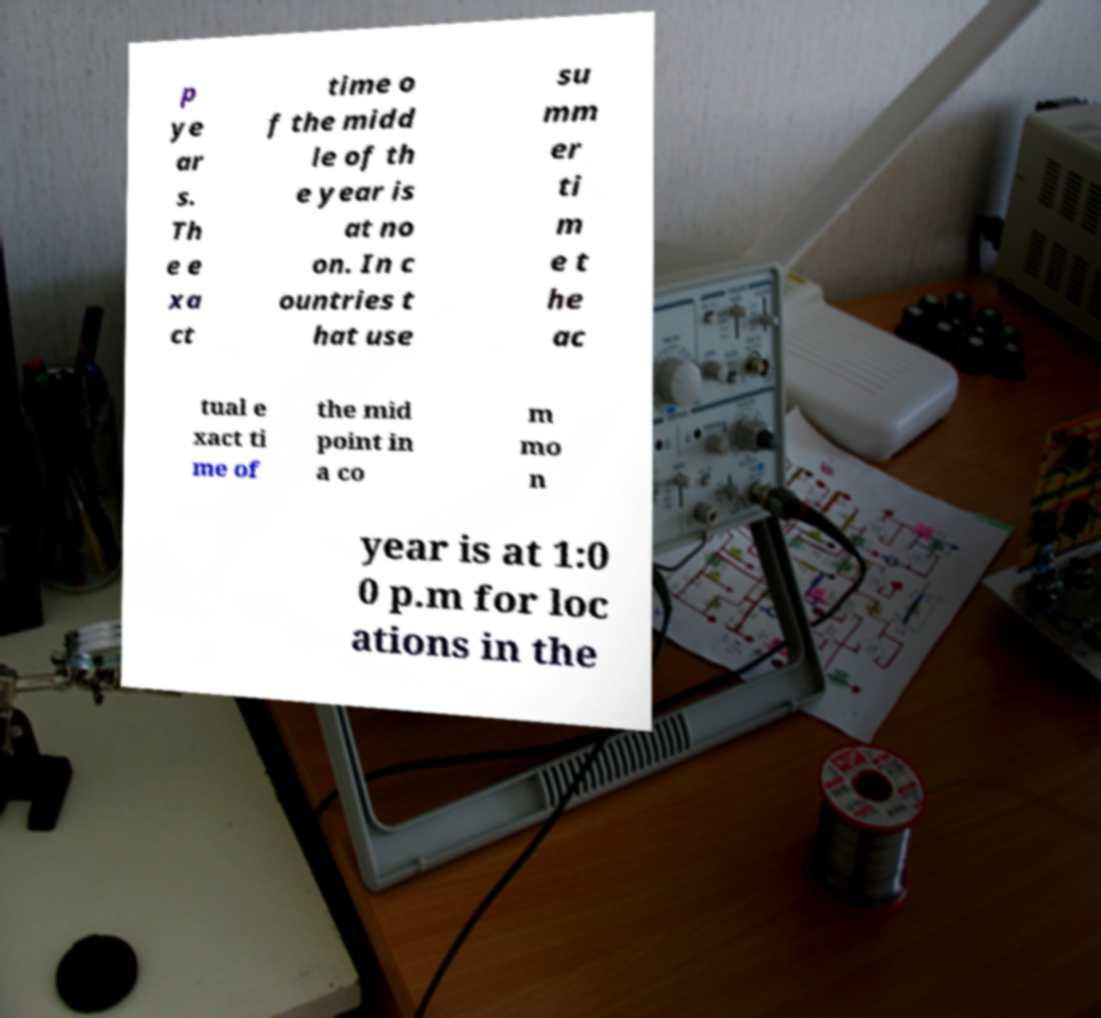Can you read and provide the text displayed in the image?This photo seems to have some interesting text. Can you extract and type it out for me? p ye ar s. Th e e xa ct time o f the midd le of th e year is at no on. In c ountries t hat use su mm er ti m e t he ac tual e xact ti me of the mid point in a co m mo n year is at 1:0 0 p.m for loc ations in the 